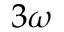Convert formula to latex. <formula><loc_0><loc_0><loc_500><loc_500>3 \omega</formula> 